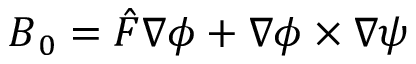Convert formula to latex. <formula><loc_0><loc_0><loc_500><loc_500>B _ { 0 } = \hat { F } \nabla \phi + \nabla \phi \times \nabla \psi</formula> 